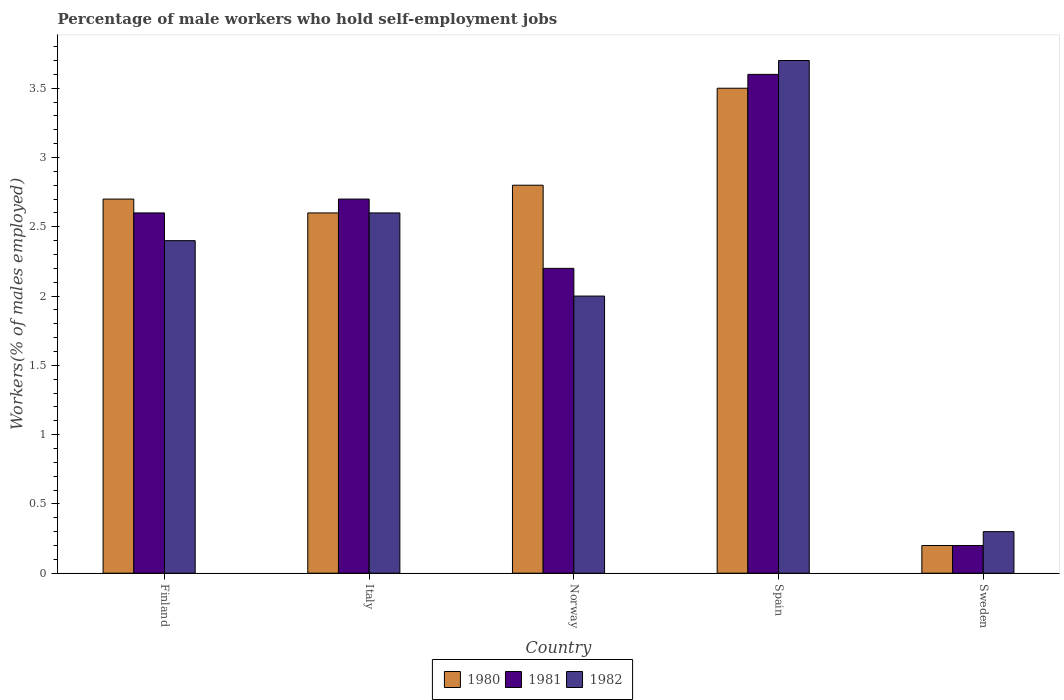How many different coloured bars are there?
Offer a terse response. 3. How many groups of bars are there?
Offer a very short reply. 5. How many bars are there on the 5th tick from the left?
Your answer should be compact. 3. What is the label of the 3rd group of bars from the left?
Keep it short and to the point. Norway. In how many cases, is the number of bars for a given country not equal to the number of legend labels?
Offer a very short reply. 0. What is the percentage of self-employed male workers in 1981 in Norway?
Keep it short and to the point. 2.2. Across all countries, what is the minimum percentage of self-employed male workers in 1981?
Provide a short and direct response. 0.2. What is the total percentage of self-employed male workers in 1981 in the graph?
Give a very brief answer. 11.3. What is the difference between the percentage of self-employed male workers in 1981 in Norway and that in Sweden?
Make the answer very short. 2. What is the difference between the percentage of self-employed male workers in 1982 in Spain and the percentage of self-employed male workers in 1980 in Norway?
Provide a succinct answer. 0.9. What is the average percentage of self-employed male workers in 1981 per country?
Your answer should be compact. 2.26. What is the difference between the percentage of self-employed male workers of/in 1982 and percentage of self-employed male workers of/in 1981 in Norway?
Your response must be concise. -0.2. What is the ratio of the percentage of self-employed male workers in 1980 in Finland to that in Italy?
Offer a terse response. 1.04. Is the difference between the percentage of self-employed male workers in 1982 in Finland and Italy greater than the difference between the percentage of self-employed male workers in 1981 in Finland and Italy?
Provide a short and direct response. No. What is the difference between the highest and the second highest percentage of self-employed male workers in 1981?
Provide a succinct answer. -0.9. What is the difference between the highest and the lowest percentage of self-employed male workers in 1981?
Your answer should be compact. 3.4. In how many countries, is the percentage of self-employed male workers in 1980 greater than the average percentage of self-employed male workers in 1980 taken over all countries?
Your answer should be compact. 4. Is the sum of the percentage of self-employed male workers in 1981 in Finland and Spain greater than the maximum percentage of self-employed male workers in 1982 across all countries?
Provide a short and direct response. Yes. What does the 1st bar from the left in Finland represents?
Keep it short and to the point. 1980. Is it the case that in every country, the sum of the percentage of self-employed male workers in 1981 and percentage of self-employed male workers in 1982 is greater than the percentage of self-employed male workers in 1980?
Make the answer very short. Yes. How many bars are there?
Your answer should be compact. 15. Are all the bars in the graph horizontal?
Give a very brief answer. No. How many countries are there in the graph?
Offer a terse response. 5. Are the values on the major ticks of Y-axis written in scientific E-notation?
Ensure brevity in your answer.  No. Does the graph contain any zero values?
Your answer should be compact. No. Where does the legend appear in the graph?
Make the answer very short. Bottom center. How many legend labels are there?
Provide a succinct answer. 3. How are the legend labels stacked?
Offer a terse response. Horizontal. What is the title of the graph?
Offer a terse response. Percentage of male workers who hold self-employment jobs. What is the label or title of the Y-axis?
Your answer should be compact. Workers(% of males employed). What is the Workers(% of males employed) in 1980 in Finland?
Your answer should be compact. 2.7. What is the Workers(% of males employed) of 1981 in Finland?
Ensure brevity in your answer.  2.6. What is the Workers(% of males employed) of 1982 in Finland?
Make the answer very short. 2.4. What is the Workers(% of males employed) in 1980 in Italy?
Make the answer very short. 2.6. What is the Workers(% of males employed) of 1981 in Italy?
Your answer should be compact. 2.7. What is the Workers(% of males employed) of 1982 in Italy?
Provide a succinct answer. 2.6. What is the Workers(% of males employed) of 1980 in Norway?
Your answer should be compact. 2.8. What is the Workers(% of males employed) in 1981 in Norway?
Your answer should be very brief. 2.2. What is the Workers(% of males employed) of 1982 in Norway?
Provide a short and direct response. 2. What is the Workers(% of males employed) in 1981 in Spain?
Provide a short and direct response. 3.6. What is the Workers(% of males employed) in 1982 in Spain?
Give a very brief answer. 3.7. What is the Workers(% of males employed) of 1980 in Sweden?
Your answer should be very brief. 0.2. What is the Workers(% of males employed) of 1981 in Sweden?
Offer a very short reply. 0.2. What is the Workers(% of males employed) in 1982 in Sweden?
Ensure brevity in your answer.  0.3. Across all countries, what is the maximum Workers(% of males employed) in 1981?
Your answer should be compact. 3.6. Across all countries, what is the maximum Workers(% of males employed) of 1982?
Provide a short and direct response. 3.7. Across all countries, what is the minimum Workers(% of males employed) of 1980?
Offer a very short reply. 0.2. Across all countries, what is the minimum Workers(% of males employed) in 1981?
Make the answer very short. 0.2. Across all countries, what is the minimum Workers(% of males employed) in 1982?
Give a very brief answer. 0.3. What is the total Workers(% of males employed) in 1982 in the graph?
Give a very brief answer. 11. What is the difference between the Workers(% of males employed) in 1982 in Finland and that in Italy?
Provide a short and direct response. -0.2. What is the difference between the Workers(% of males employed) of 1981 in Finland and that in Norway?
Provide a succinct answer. 0.4. What is the difference between the Workers(% of males employed) in 1982 in Finland and that in Norway?
Provide a succinct answer. 0.4. What is the difference between the Workers(% of males employed) in 1980 in Finland and that in Spain?
Offer a very short reply. -0.8. What is the difference between the Workers(% of males employed) in 1981 in Finland and that in Sweden?
Give a very brief answer. 2.4. What is the difference between the Workers(% of males employed) in 1982 in Finland and that in Sweden?
Make the answer very short. 2.1. What is the difference between the Workers(% of males employed) of 1982 in Italy and that in Norway?
Ensure brevity in your answer.  0.6. What is the difference between the Workers(% of males employed) of 1981 in Italy and that in Spain?
Keep it short and to the point. -0.9. What is the difference between the Workers(% of males employed) of 1982 in Italy and that in Spain?
Provide a short and direct response. -1.1. What is the difference between the Workers(% of males employed) of 1980 in Italy and that in Sweden?
Keep it short and to the point. 2.4. What is the difference between the Workers(% of males employed) of 1981 in Italy and that in Sweden?
Keep it short and to the point. 2.5. What is the difference between the Workers(% of males employed) of 1982 in Italy and that in Sweden?
Keep it short and to the point. 2.3. What is the difference between the Workers(% of males employed) in 1980 in Norway and that in Spain?
Offer a terse response. -0.7. What is the difference between the Workers(% of males employed) of 1982 in Norway and that in Spain?
Offer a terse response. -1.7. What is the difference between the Workers(% of males employed) of 1980 in Norway and that in Sweden?
Keep it short and to the point. 2.6. What is the difference between the Workers(% of males employed) of 1982 in Norway and that in Sweden?
Give a very brief answer. 1.7. What is the difference between the Workers(% of males employed) of 1980 in Spain and that in Sweden?
Make the answer very short. 3.3. What is the difference between the Workers(% of males employed) in 1980 in Finland and the Workers(% of males employed) in 1981 in Italy?
Make the answer very short. 0. What is the difference between the Workers(% of males employed) in 1980 in Finland and the Workers(% of males employed) in 1982 in Italy?
Give a very brief answer. 0.1. What is the difference between the Workers(% of males employed) in 1980 in Finland and the Workers(% of males employed) in 1981 in Norway?
Make the answer very short. 0.5. What is the difference between the Workers(% of males employed) in 1980 in Finland and the Workers(% of males employed) in 1982 in Norway?
Provide a short and direct response. 0.7. What is the difference between the Workers(% of males employed) of 1980 in Finland and the Workers(% of males employed) of 1981 in Spain?
Offer a very short reply. -0.9. What is the difference between the Workers(% of males employed) in 1981 in Finland and the Workers(% of males employed) in 1982 in Spain?
Your answer should be compact. -1.1. What is the difference between the Workers(% of males employed) of 1980 in Finland and the Workers(% of males employed) of 1982 in Sweden?
Your answer should be compact. 2.4. What is the difference between the Workers(% of males employed) in 1981 in Finland and the Workers(% of males employed) in 1982 in Sweden?
Ensure brevity in your answer.  2.3. What is the difference between the Workers(% of males employed) in 1980 in Italy and the Workers(% of males employed) in 1982 in Norway?
Provide a short and direct response. 0.6. What is the difference between the Workers(% of males employed) of 1981 in Italy and the Workers(% of males employed) of 1982 in Norway?
Provide a succinct answer. 0.7. What is the difference between the Workers(% of males employed) of 1980 in Italy and the Workers(% of males employed) of 1981 in Spain?
Your answer should be compact. -1. What is the difference between the Workers(% of males employed) of 1980 in Italy and the Workers(% of males employed) of 1982 in Spain?
Your answer should be compact. -1.1. What is the difference between the Workers(% of males employed) in 1980 in Italy and the Workers(% of males employed) in 1981 in Sweden?
Make the answer very short. 2.4. What is the difference between the Workers(% of males employed) in 1980 in Italy and the Workers(% of males employed) in 1982 in Sweden?
Offer a terse response. 2.3. What is the difference between the Workers(% of males employed) of 1981 in Italy and the Workers(% of males employed) of 1982 in Sweden?
Ensure brevity in your answer.  2.4. What is the difference between the Workers(% of males employed) of 1980 in Norway and the Workers(% of males employed) of 1981 in Spain?
Ensure brevity in your answer.  -0.8. What is the difference between the Workers(% of males employed) in 1980 in Norway and the Workers(% of males employed) in 1982 in Spain?
Make the answer very short. -0.9. What is the difference between the Workers(% of males employed) of 1981 in Norway and the Workers(% of males employed) of 1982 in Spain?
Your answer should be very brief. -1.5. What is the difference between the Workers(% of males employed) in 1980 in Norway and the Workers(% of males employed) in 1982 in Sweden?
Provide a short and direct response. 2.5. What is the difference between the Workers(% of males employed) in 1981 in Norway and the Workers(% of males employed) in 1982 in Sweden?
Your response must be concise. 1.9. What is the difference between the Workers(% of males employed) in 1981 in Spain and the Workers(% of males employed) in 1982 in Sweden?
Provide a short and direct response. 3.3. What is the average Workers(% of males employed) in 1980 per country?
Give a very brief answer. 2.36. What is the average Workers(% of males employed) of 1981 per country?
Make the answer very short. 2.26. What is the difference between the Workers(% of males employed) of 1980 and Workers(% of males employed) of 1981 in Finland?
Your answer should be compact. 0.1. What is the difference between the Workers(% of males employed) in 1981 and Workers(% of males employed) in 1982 in Finland?
Provide a short and direct response. 0.2. What is the difference between the Workers(% of males employed) in 1980 and Workers(% of males employed) in 1982 in Italy?
Offer a very short reply. 0. What is the difference between the Workers(% of males employed) of 1981 and Workers(% of males employed) of 1982 in Italy?
Ensure brevity in your answer.  0.1. What is the difference between the Workers(% of males employed) of 1980 and Workers(% of males employed) of 1981 in Norway?
Give a very brief answer. 0.6. What is the difference between the Workers(% of males employed) of 1981 and Workers(% of males employed) of 1982 in Spain?
Offer a terse response. -0.1. What is the difference between the Workers(% of males employed) of 1980 and Workers(% of males employed) of 1981 in Sweden?
Provide a short and direct response. 0. What is the difference between the Workers(% of males employed) of 1980 and Workers(% of males employed) of 1982 in Sweden?
Your response must be concise. -0.1. What is the ratio of the Workers(% of males employed) of 1982 in Finland to that in Italy?
Provide a succinct answer. 0.92. What is the ratio of the Workers(% of males employed) in 1980 in Finland to that in Norway?
Your answer should be compact. 0.96. What is the ratio of the Workers(% of males employed) in 1981 in Finland to that in Norway?
Provide a succinct answer. 1.18. What is the ratio of the Workers(% of males employed) of 1980 in Finland to that in Spain?
Provide a succinct answer. 0.77. What is the ratio of the Workers(% of males employed) in 1981 in Finland to that in Spain?
Keep it short and to the point. 0.72. What is the ratio of the Workers(% of males employed) of 1982 in Finland to that in Spain?
Make the answer very short. 0.65. What is the ratio of the Workers(% of males employed) in 1980 in Finland to that in Sweden?
Your answer should be very brief. 13.5. What is the ratio of the Workers(% of males employed) in 1981 in Finland to that in Sweden?
Your response must be concise. 13. What is the ratio of the Workers(% of males employed) in 1981 in Italy to that in Norway?
Ensure brevity in your answer.  1.23. What is the ratio of the Workers(% of males employed) in 1982 in Italy to that in Norway?
Keep it short and to the point. 1.3. What is the ratio of the Workers(% of males employed) of 1980 in Italy to that in Spain?
Your answer should be very brief. 0.74. What is the ratio of the Workers(% of males employed) of 1982 in Italy to that in Spain?
Offer a terse response. 0.7. What is the ratio of the Workers(% of males employed) of 1980 in Italy to that in Sweden?
Give a very brief answer. 13. What is the ratio of the Workers(% of males employed) of 1982 in Italy to that in Sweden?
Keep it short and to the point. 8.67. What is the ratio of the Workers(% of males employed) of 1981 in Norway to that in Spain?
Provide a short and direct response. 0.61. What is the ratio of the Workers(% of males employed) of 1982 in Norway to that in Spain?
Provide a short and direct response. 0.54. What is the ratio of the Workers(% of males employed) of 1980 in Norway to that in Sweden?
Give a very brief answer. 14. What is the ratio of the Workers(% of males employed) of 1981 in Norway to that in Sweden?
Your response must be concise. 11. What is the ratio of the Workers(% of males employed) of 1981 in Spain to that in Sweden?
Provide a short and direct response. 18. What is the ratio of the Workers(% of males employed) in 1982 in Spain to that in Sweden?
Offer a very short reply. 12.33. What is the difference between the highest and the second highest Workers(% of males employed) of 1981?
Your answer should be very brief. 0.9. What is the difference between the highest and the second highest Workers(% of males employed) of 1982?
Offer a very short reply. 1.1. What is the difference between the highest and the lowest Workers(% of males employed) in 1980?
Your answer should be very brief. 3.3. What is the difference between the highest and the lowest Workers(% of males employed) in 1982?
Make the answer very short. 3.4. 